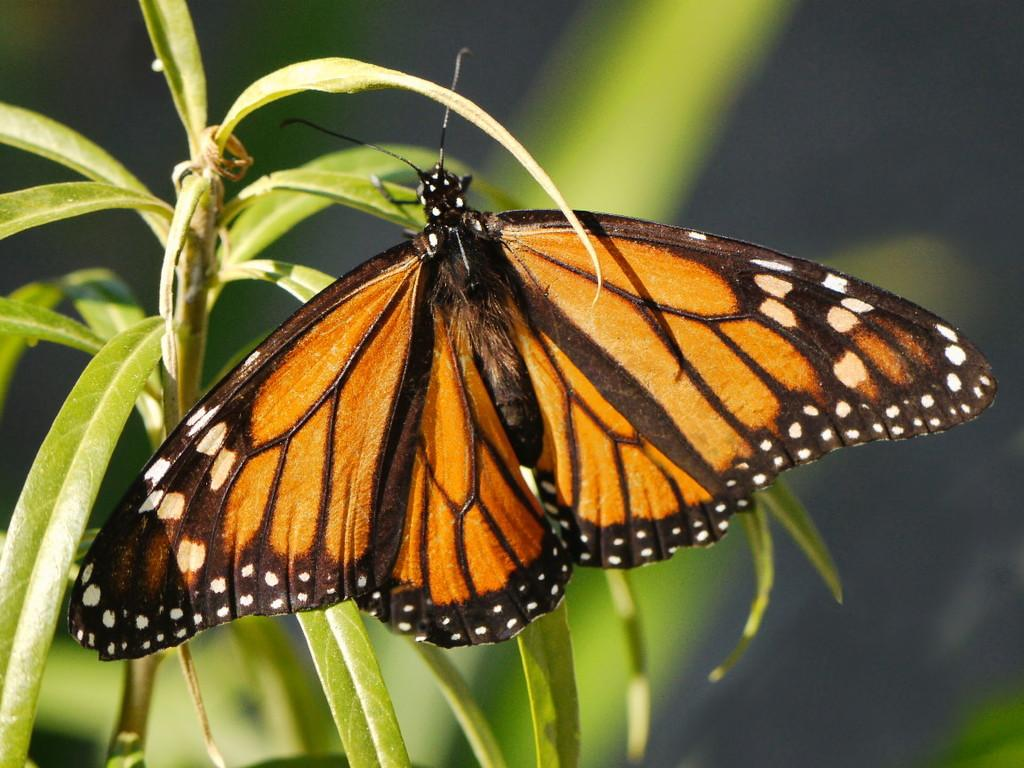What is the main subject of the image? The main subject of the image is a butterfly. Where is the butterfly located in the image? The butterfly is on the leaves. What type of friend can be seen interacting with the butterfly in the image? There is no friend present in the image; it only features a butterfly on the leaves. What is the aftermath of the butterfly's interaction with the leaves in the image? There is no aftermath to describe, as the image only shows the butterfly on the leaves and does not depict any interaction or event. 